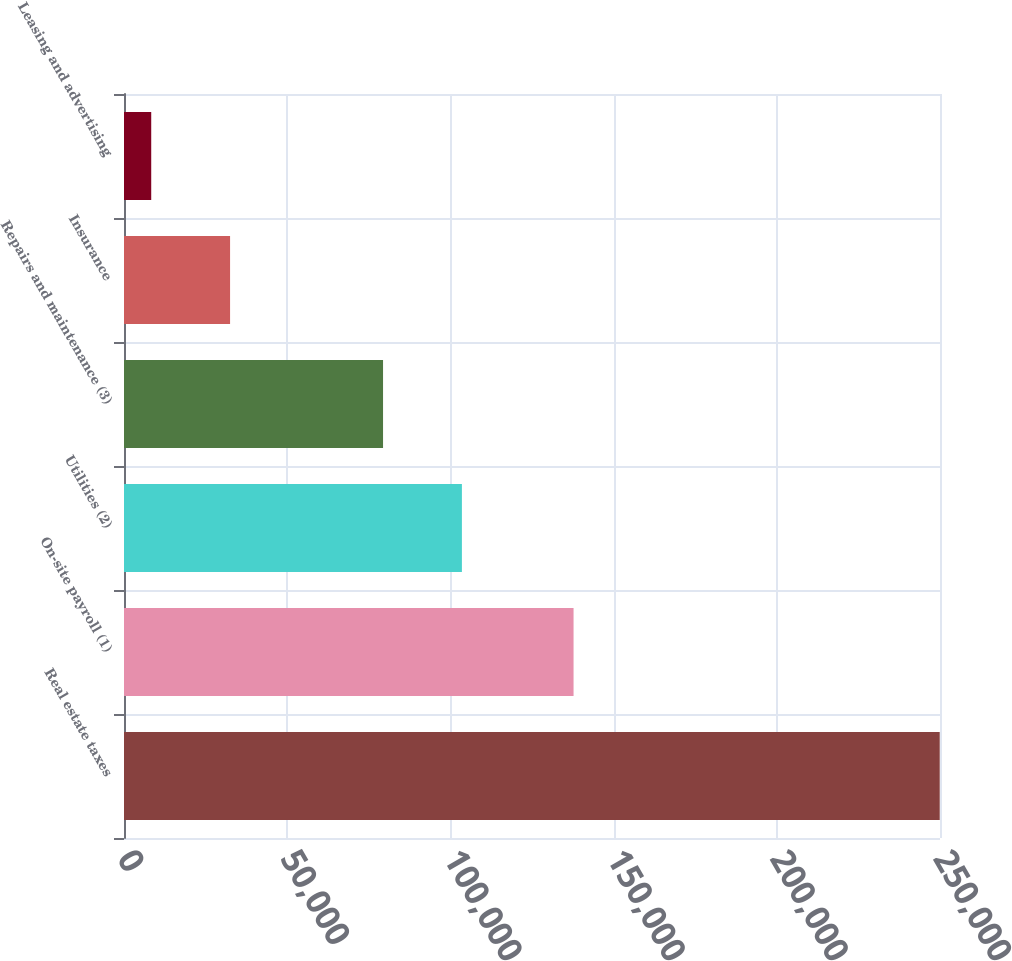<chart> <loc_0><loc_0><loc_500><loc_500><bar_chart><fcel>Real estate taxes<fcel>On-site payroll (1)<fcel>Utilities (2)<fcel>Repairs and maintenance (3)<fcel>Insurance<fcel>Leasing and advertising<nl><fcel>249916<fcel>137731<fcel>103524<fcel>79366<fcel>32498.5<fcel>8341<nl></chart> 